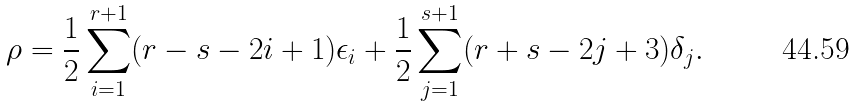Convert formula to latex. <formula><loc_0><loc_0><loc_500><loc_500>\rho = \frac { 1 } { 2 } \sum _ { i = 1 } ^ { r + 1 } ( r - s - 2 i + 1 ) \epsilon _ { i } + \frac { 1 } { 2 } \sum _ { j = 1 } ^ { s + 1 } ( r + s - 2 j + 3 ) \delta _ { j } .</formula> 